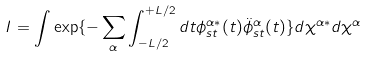Convert formula to latex. <formula><loc_0><loc_0><loc_500><loc_500>I = \int \exp \{ - \sum _ { \alpha } \int _ { - L / 2 } ^ { + L / 2 } d t \phi ^ { \alpha * } _ { s t } ( t ) \ddot { \phi } ^ { \alpha } _ { s t } ( t ) \} d \chi ^ { \alpha * } d \chi ^ { \alpha }</formula> 